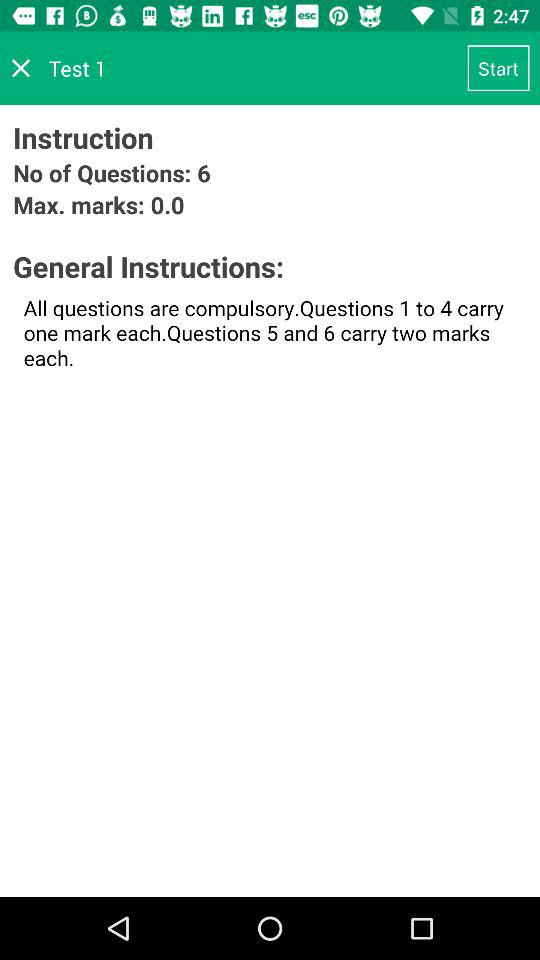What's the score of question number 5? The score of question number 5 is two marks. 